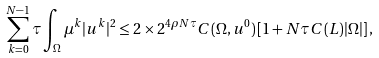<formula> <loc_0><loc_0><loc_500><loc_500>\sum _ { k = 0 } ^ { N - 1 } \tau \int _ { \Omega } \mu ^ { k } | u ^ { k } | ^ { 2 } \leq 2 \times 2 ^ { 4 \rho N \tau } C ( \Omega , u ^ { 0 } ) \left [ 1 + N \tau C ( L ) | \Omega | \right ] ,</formula> 